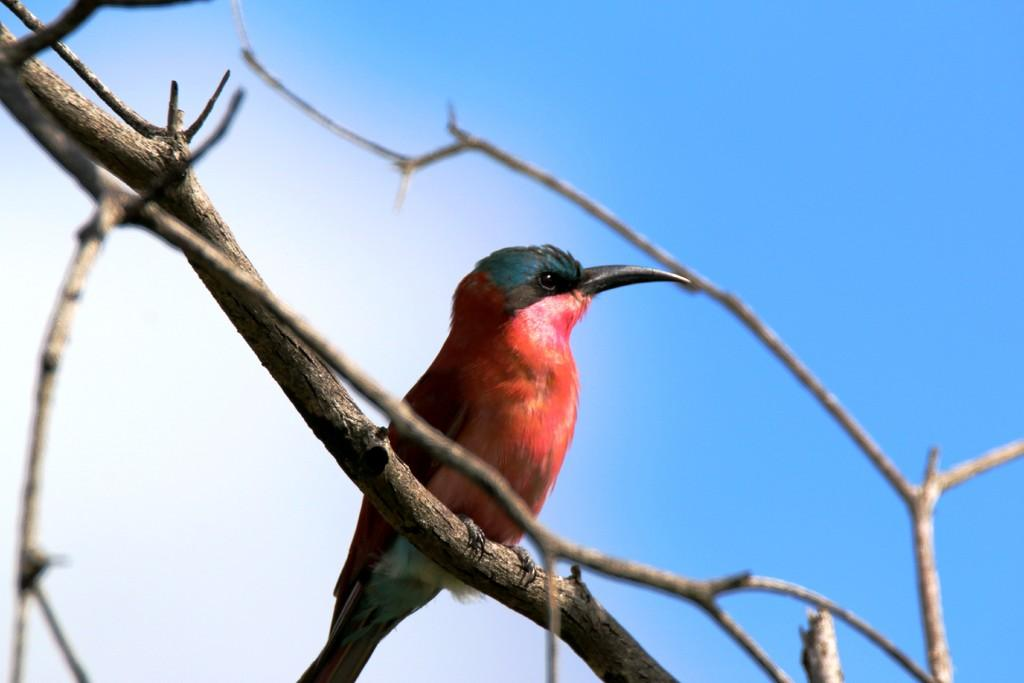What type of animal can be seen in the image? There is a bird in the picture. What is the bird standing on? The bird is standing on dried stems. What can be seen in the background of the image? The sky is visible in the background of the image. What type of appliance is the bird using to walk in the image? There is no appliance present in the image, and the bird is not walking; it is standing on dried stems. 